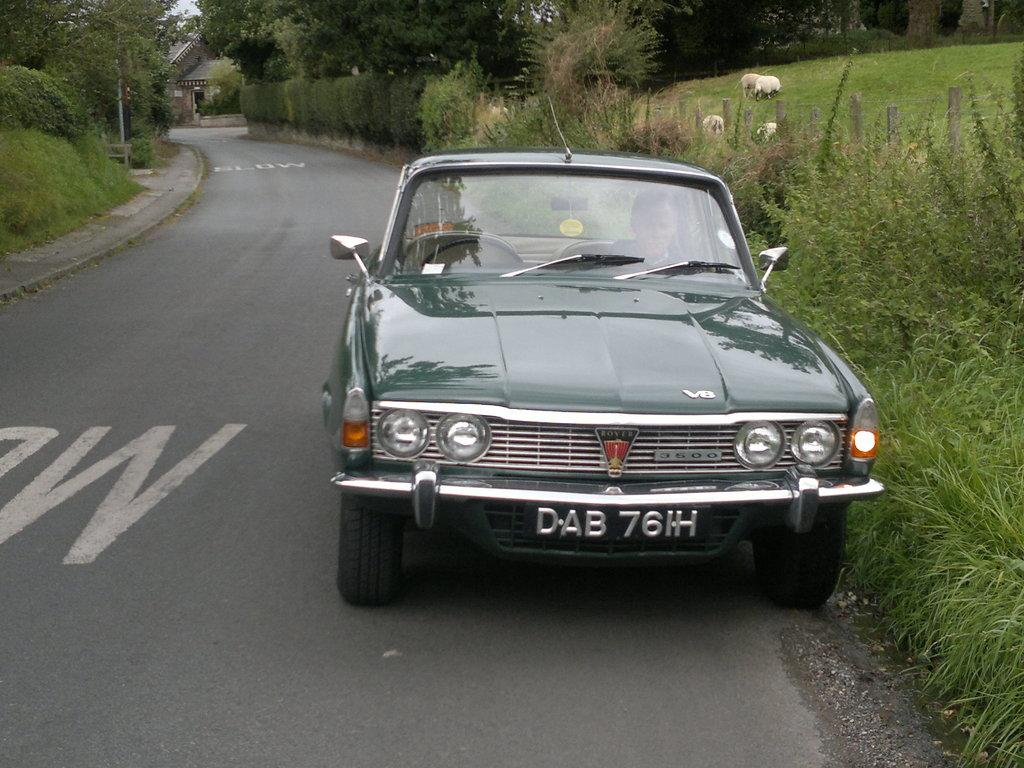What type of vehicle is in the image? There is a green car in the image. What can be seen in the background of the image? There is a house and green trees in the background of the image. What is the color of the sky in the image? The sky appears to be white in the image. Are there any shoes visible in the image? There are no shoes present in the image. Does the existence of the green car in the image prove the existence of extraterrestrial life? The existence of the green car in the image does not prove the existence of extraterrestrial life, as the car is a terrestrial vehicle. 